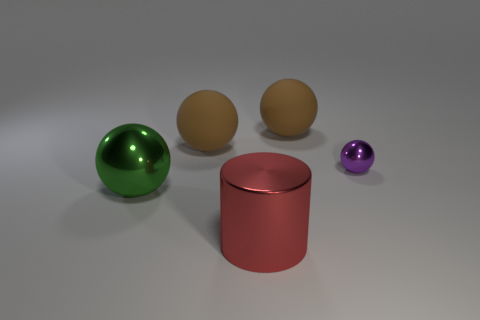Subtract all small purple shiny spheres. How many spheres are left? 3 Subtract all brown blocks. How many brown balls are left? 2 Subtract all green balls. How many balls are left? 3 Add 2 blue cylinders. How many objects exist? 7 Subtract all spheres. How many objects are left? 1 Subtract all red spheres. Subtract all gray cylinders. How many spheres are left? 4 Add 2 tiny blue rubber cylinders. How many tiny blue rubber cylinders exist? 2 Subtract 0 gray spheres. How many objects are left? 5 Subtract all purple shiny spheres. Subtract all large metal cylinders. How many objects are left? 3 Add 2 metallic cylinders. How many metallic cylinders are left? 3 